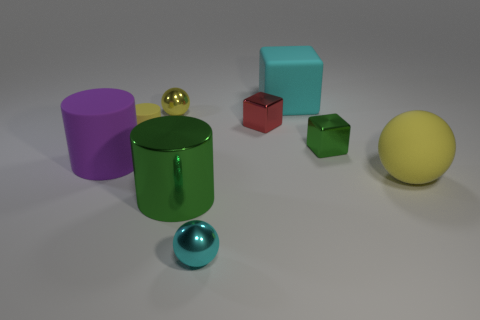Subtract all purple matte cylinders. How many cylinders are left? 2 Subtract all yellow cylinders. How many cylinders are left? 2 Subtract all spheres. How many objects are left? 6 Add 1 big shiny things. How many objects exist? 10 Subtract 2 blocks. How many blocks are left? 1 Add 8 yellow cylinders. How many yellow cylinders are left? 9 Add 6 green things. How many green things exist? 8 Subtract 1 cyan cubes. How many objects are left? 8 Subtract all cyan cylinders. Subtract all blue cubes. How many cylinders are left? 3 Subtract all gray cubes. How many cyan cylinders are left? 0 